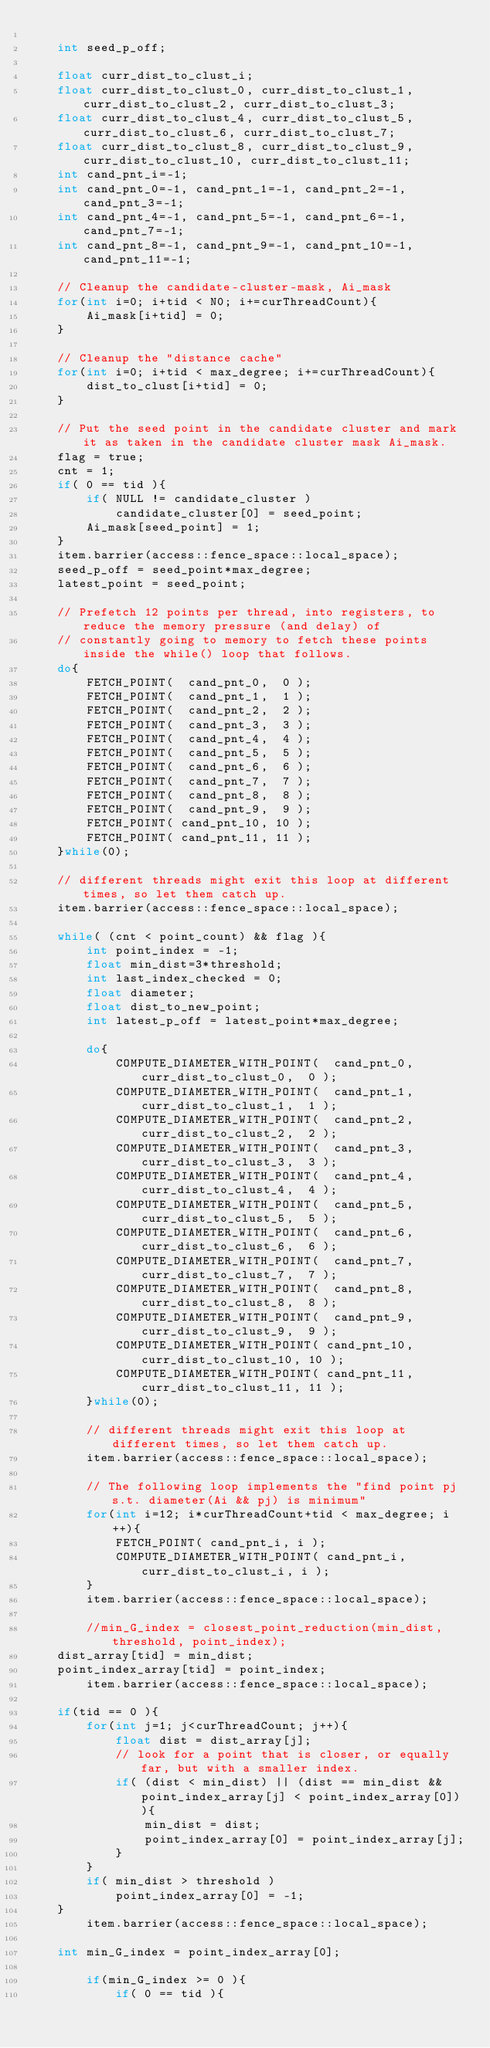Convert code to text. <code><loc_0><loc_0><loc_500><loc_500><_C_>
    int seed_p_off;

    float curr_dist_to_clust_i;
    float curr_dist_to_clust_0, curr_dist_to_clust_1, curr_dist_to_clust_2, curr_dist_to_clust_3;
    float curr_dist_to_clust_4, curr_dist_to_clust_5, curr_dist_to_clust_6, curr_dist_to_clust_7;
    float curr_dist_to_clust_8, curr_dist_to_clust_9, curr_dist_to_clust_10, curr_dist_to_clust_11;
    int cand_pnt_i=-1;
    int cand_pnt_0=-1, cand_pnt_1=-1, cand_pnt_2=-1, cand_pnt_3=-1;
    int cand_pnt_4=-1, cand_pnt_5=-1, cand_pnt_6=-1, cand_pnt_7=-1;
    int cand_pnt_8=-1, cand_pnt_9=-1, cand_pnt_10=-1, cand_pnt_11=-1;

    // Cleanup the candidate-cluster-mask, Ai_mask
    for(int i=0; i+tid < N0; i+=curThreadCount){
        Ai_mask[i+tid] = 0;
    }

    // Cleanup the "distance cache"
    for(int i=0; i+tid < max_degree; i+=curThreadCount){
        dist_to_clust[i+tid] = 0;
    }

    // Put the seed point in the candidate cluster and mark it as taken in the candidate cluster mask Ai_mask.
    flag = true;
    cnt = 1;
    if( 0 == tid ){
        if( NULL != candidate_cluster )
            candidate_cluster[0] = seed_point;
        Ai_mask[seed_point] = 1;
    }
    item.barrier(access::fence_space::local_space);
    seed_p_off = seed_point*max_degree;
    latest_point = seed_point;

    // Prefetch 12 points per thread, into registers, to reduce the memory pressure (and delay) of
    // constantly going to memory to fetch these points inside the while() loop that follows.
    do{
        FETCH_POINT(  cand_pnt_0,  0 );
        FETCH_POINT(  cand_pnt_1,  1 );
        FETCH_POINT(  cand_pnt_2,  2 );
        FETCH_POINT(  cand_pnt_3,  3 );
        FETCH_POINT(  cand_pnt_4,  4 );
        FETCH_POINT(  cand_pnt_5,  5 );
        FETCH_POINT(  cand_pnt_6,  6 );
        FETCH_POINT(  cand_pnt_7,  7 );
        FETCH_POINT(  cand_pnt_8,  8 );
        FETCH_POINT(  cand_pnt_9,  9 );
        FETCH_POINT( cand_pnt_10, 10 );
        FETCH_POINT( cand_pnt_11, 11 );
    }while(0);

    // different threads might exit this loop at different times, so let them catch up.
    item.barrier(access::fence_space::local_space);

    while( (cnt < point_count) && flag ){
        int point_index = -1;
        float min_dist=3*threshold;
        int last_index_checked = 0;
        float diameter;
        float dist_to_new_point;
        int latest_p_off = latest_point*max_degree;

        do{
            COMPUTE_DIAMETER_WITH_POINT(  cand_pnt_0,  curr_dist_to_clust_0,  0 );
            COMPUTE_DIAMETER_WITH_POINT(  cand_pnt_1,  curr_dist_to_clust_1,  1 );
            COMPUTE_DIAMETER_WITH_POINT(  cand_pnt_2,  curr_dist_to_clust_2,  2 );
            COMPUTE_DIAMETER_WITH_POINT(  cand_pnt_3,  curr_dist_to_clust_3,  3 );
            COMPUTE_DIAMETER_WITH_POINT(  cand_pnt_4,  curr_dist_to_clust_4,  4 );
            COMPUTE_DIAMETER_WITH_POINT(  cand_pnt_5,  curr_dist_to_clust_5,  5 );
            COMPUTE_DIAMETER_WITH_POINT(  cand_pnt_6,  curr_dist_to_clust_6,  6 );
            COMPUTE_DIAMETER_WITH_POINT(  cand_pnt_7,  curr_dist_to_clust_7,  7 );
            COMPUTE_DIAMETER_WITH_POINT(  cand_pnt_8,  curr_dist_to_clust_8,  8 );
            COMPUTE_DIAMETER_WITH_POINT(  cand_pnt_9,  curr_dist_to_clust_9,  9 );
            COMPUTE_DIAMETER_WITH_POINT( cand_pnt_10, curr_dist_to_clust_10, 10 );
            COMPUTE_DIAMETER_WITH_POINT( cand_pnt_11, curr_dist_to_clust_11, 11 );
        }while(0);

        // different threads might exit this loop at different times, so let them catch up.
        item.barrier(access::fence_space::local_space);

        // The following loop implements the "find point pj s.t. diameter(Ai && pj) is minimum"
        for(int i=12; i*curThreadCount+tid < max_degree; i++){
            FETCH_POINT( cand_pnt_i, i );
            COMPUTE_DIAMETER_WITH_POINT( cand_pnt_i, curr_dist_to_clust_i, i );
        }
        item.barrier(access::fence_space::local_space);

        //min_G_index = closest_point_reduction(min_dist, threshold, point_index);
    dist_array[tid] = min_dist;
    point_index_array[tid] = point_index;
        item.barrier(access::fence_space::local_space);

    if(tid == 0 ){
        for(int j=1; j<curThreadCount; j++){
            float dist = dist_array[j];
            // look for a point that is closer, or equally far, but with a smaller index.
            if( (dist < min_dist) || (dist == min_dist && point_index_array[j] < point_index_array[0]) ){
                min_dist = dist;
                point_index_array[0] = point_index_array[j];
            }
        }
        if( min_dist > threshold )
            point_index_array[0] = -1;
    }
        item.barrier(access::fence_space::local_space);

    int min_G_index = point_index_array[0];

        if(min_G_index >= 0 ){
            if( 0 == tid ){</code> 